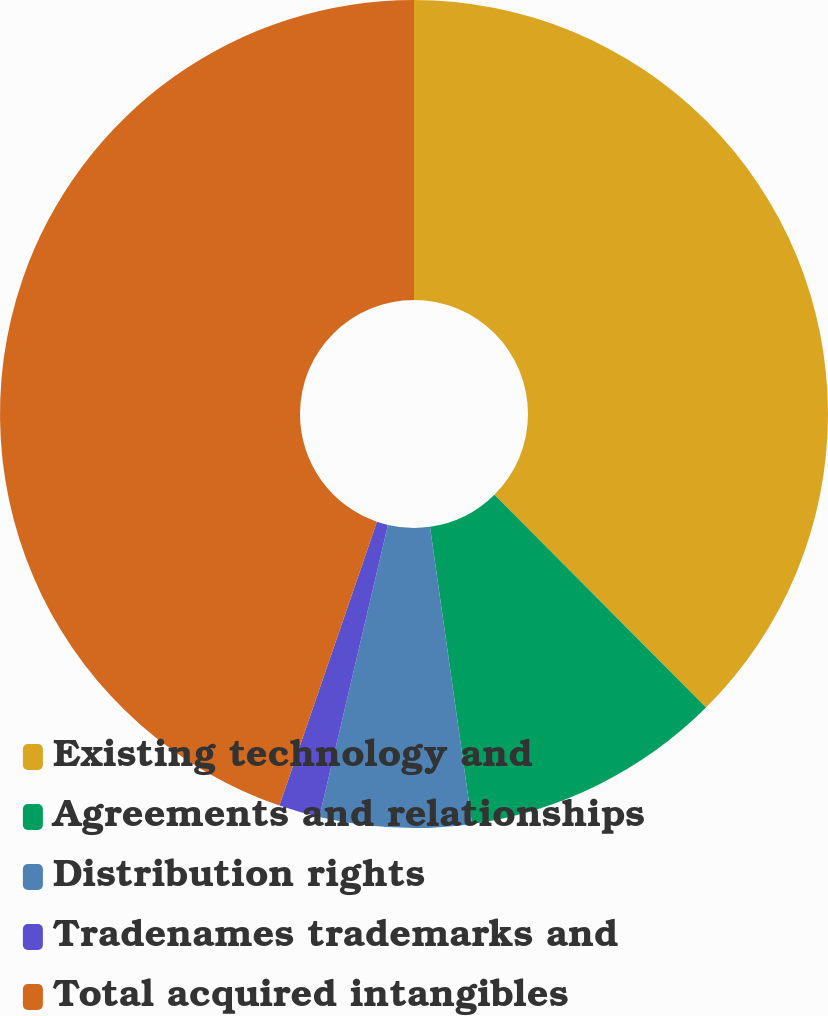Convert chart to OTSL. <chart><loc_0><loc_0><loc_500><loc_500><pie_chart><fcel>Existing technology and<fcel>Agreements and relationships<fcel>Distribution rights<fcel>Tradenames trademarks and<fcel>Total acquired intangibles<nl><fcel>37.54%<fcel>10.22%<fcel>5.91%<fcel>1.6%<fcel>44.73%<nl></chart> 